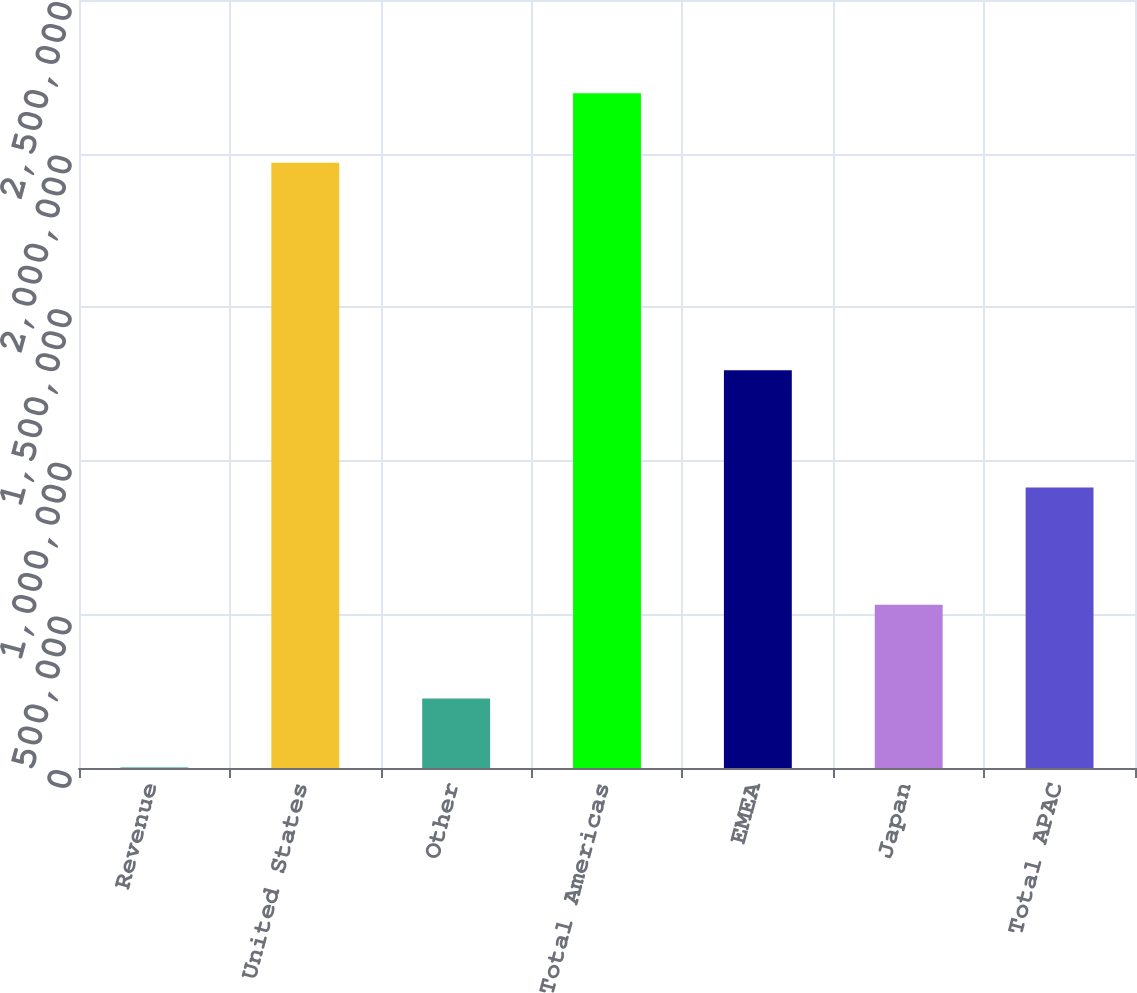Convert chart to OTSL. <chart><loc_0><loc_0><loc_500><loc_500><bar_chart><fcel>Revenue<fcel>United States<fcel>Other<fcel>Total Americas<fcel>EMEA<fcel>Japan<fcel>Total APAC<nl><fcel>2012<fcel>1.96992e+06<fcel>226430<fcel>2.19635e+06<fcel>1.29457e+06<fcel>531028<fcel>912757<nl></chart> 